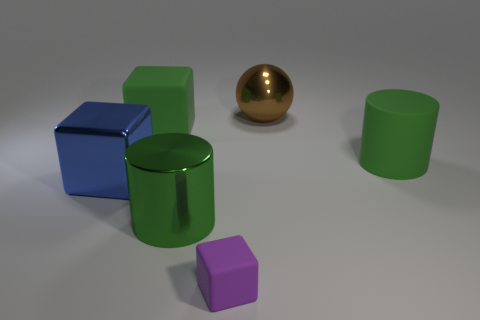Do the big shiny cylinder and the large matte object that is left of the metallic ball have the same color?
Offer a very short reply. Yes. There is a big green cylinder that is behind the big green cylinder left of the large green matte object that is right of the purple rubber object; what is its material?
Ensure brevity in your answer.  Rubber. There is a brown sphere; is its size the same as the rubber object to the right of the large brown metal object?
Your answer should be very brief. Yes. What number of things are big green matte things that are in front of the green matte block or green cylinders that are behind the metal cylinder?
Your answer should be compact. 1. What is the color of the large matte object that is to the left of the purple thing?
Make the answer very short. Green. There is a green thing to the right of the big brown object; is there a big green object that is behind it?
Your response must be concise. Yes. Is the number of large blue cubes less than the number of small green shiny objects?
Offer a very short reply. No. What material is the purple cube on the right side of the big metal thing in front of the blue object?
Offer a very short reply. Rubber. Is the shiny cylinder the same size as the purple thing?
Offer a terse response. No. How many objects are small red matte cylinders or brown metallic objects?
Offer a very short reply. 1. 